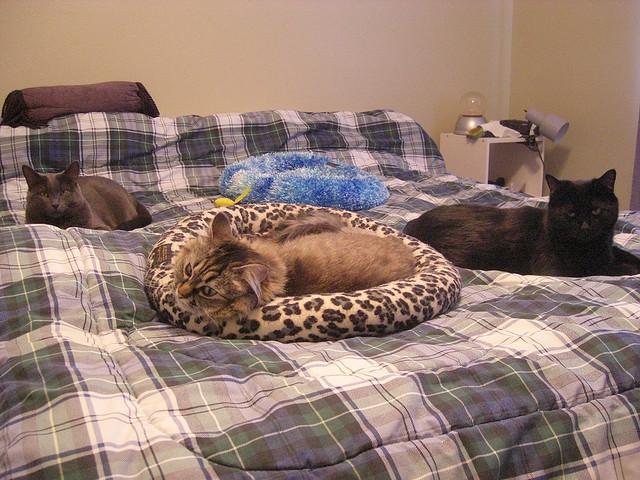How many cats are there?
Short answer required. 3. What piece of furniture are the cats sitting on?
Concise answer only. Bed. Where are the cats?
Keep it brief. On bed. 